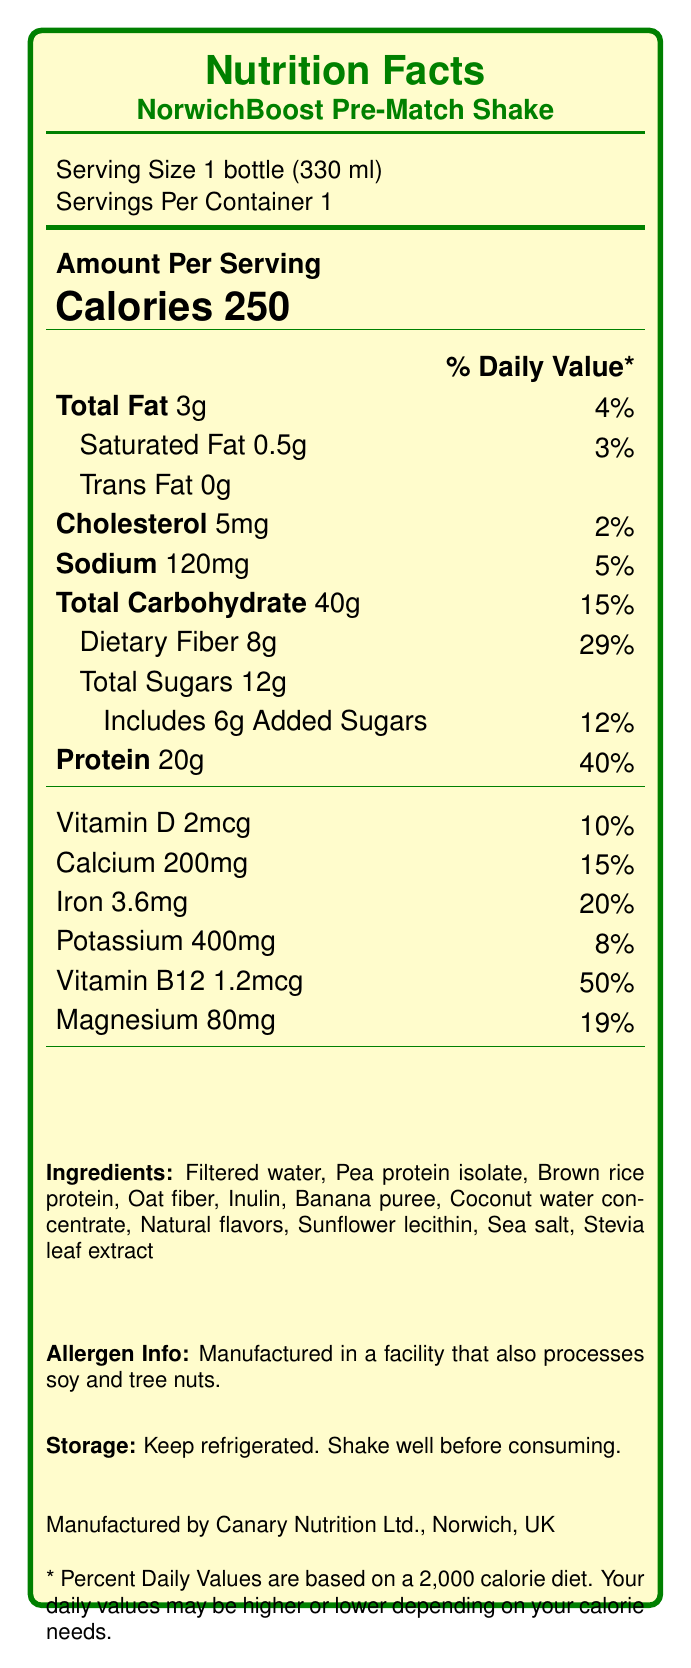what is the serving size of the NorwichBoost Pre-Match Shake? The serving size is clearly stated as "1 bottle (330 ml)" on the Nutrition Facts Label.
Answer: 1 bottle (330 ml) how many grams of total fat are in one serving? The label shows "Total Fat 3g."
Answer: 3 grams what is the percentage of the Daily Value for dietary fiber in the shake? The Daily Value for dietary fiber is given as 29% on the Nutrition Facts Label.
Answer: 29% how many grams of protein are present in the NorwichBoost Pre-Match Shake? The label indicates that there are 20 grams of protein per serving.
Answer: 20 grams what is the main protein source in the NorwichBoost Pre-Match Shake? The ingredients list mentions "Pea protein isolate" and "Brown rice protein" as the protein sources.
Answer: Pea protein isolate and Brown rice protein which nutrient has the highest percentage of the Daily Value in this product? A. Vitamin D B. Iron C. Vitamin B12 Vitamin B12 has a Daily Value percentage of 50%, which is higher than the other listed options.
Answer: C. Vitamin B12 how much calcium is in the NorwichBoost Pre-Match Shake? A. 100mg B. 150mg C. 200mg The Nutrition Facts Label shows that the shake contains 200mg of calcium.
Answer: C. 200mg does the product contain any trans fat? The Nutrition Facts Label lists the amount of trans fat as 0g.
Answer: No is there any cholesterol in the NorwichBoost Pre-Match Shake? The label shows "Cholesterol 5mg," indicating the presence of cholesterol.
Answer: Yes summarize the main idea of the NorwichBoost Pre-Match Shake's Nutrition Facts Label. This summary encapsulates the key nutritional information, ingredients, and storage instructions of the shake as detailed on the Nutrition Facts Label.
Answer: The NorwichBoost Pre-Match Shake is a low-fat, high-fiber nutritional drink designed for athletes, providing 250 calories per serving. It contains 20g of protein, 3g of total fat, 40g of total carbohydrates including 8g dietary fiber, and various vitamins and minerals. It is made with ingredients including pea protein isolate, brown rice protein, and banana puree, and should be kept refrigerated. how much added sugar does the shake contain? The label specifies that the shake includes 6g of added sugars.
Answer: 6 grams what is the manufacturer's name and location? The information about the manufacturer is stated on the label as "Manufactured by Canary Nutrition Ltd., Norwich, UK."
Answer: Canary Nutrition Ltd., Norwich, UK is there enough information to determine if the product is gluten-free? The label does not provide information regarding whether the product is gluten-free. It only lists allergen information related to soy and tree nuts.
Answer: Not enough information 